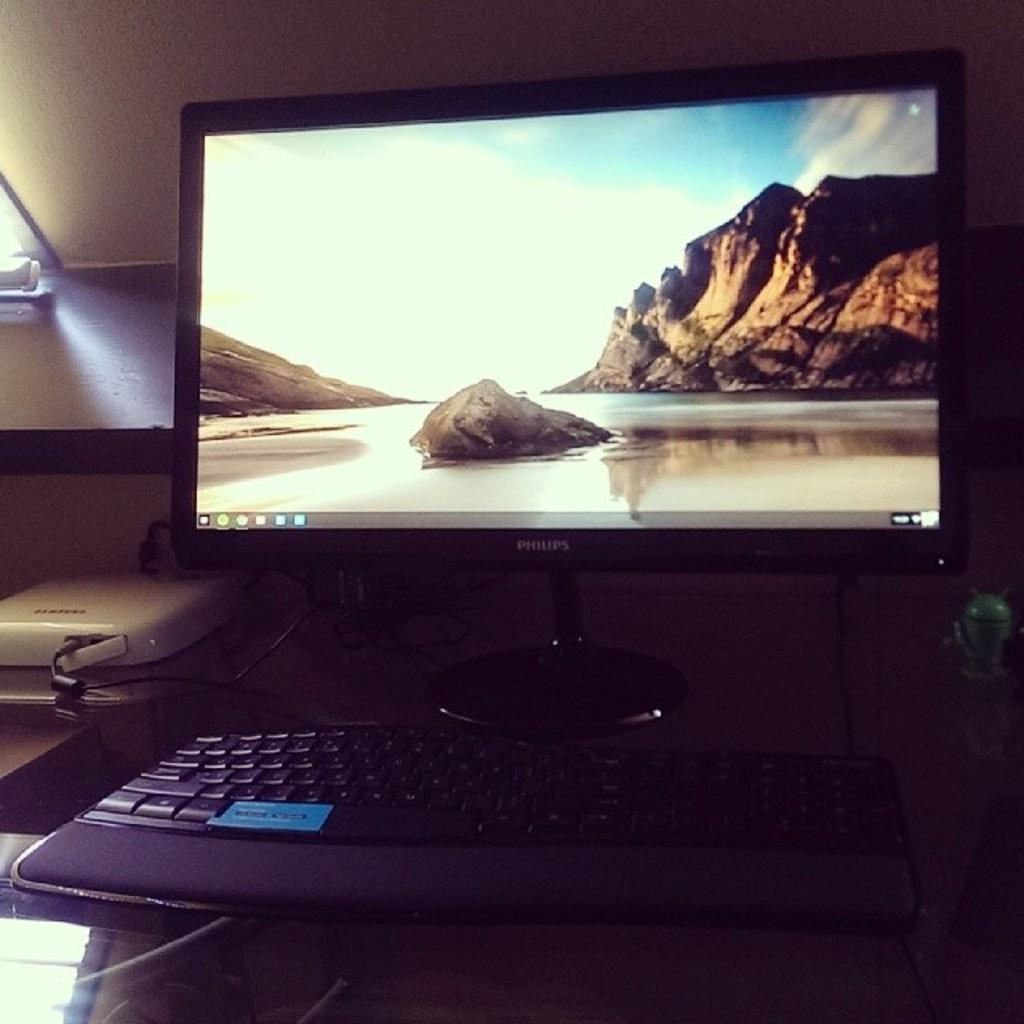<image>
Render a clear and concise summary of the photo. A beach scene with a rocky cliff is displayed on the Philips monitor. 